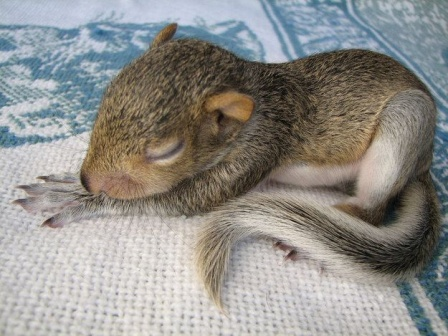What is this photo about? This enchanting photograph captures the serene moment of a baby squirrel peacefully slumbering on a woven blanket, adorned with a geometric pattern in varying shades of blue and white. The squirrel, with its soft, brown-and-gray fur, is curled up gracefully, exuding a sense of warmth and security. The tiny, delicate creature rests its head gently on its front paws while its bushy tail wraps around its petite body, adding to the cozy and tranquil ambiance. This intimate portrayal of innocence and tranquility underscores the beauty of nature's simpler moments, with no other objects or text intruding upon the scene. 